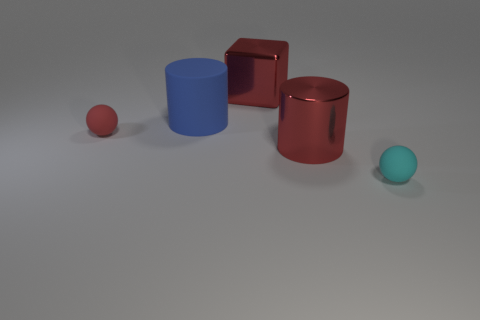Is the shape of the cyan matte thing the same as the red matte thing?
Offer a terse response. Yes. What is the material of the sphere that is the same color as the large cube?
Offer a terse response. Rubber. Is the color of the large shiny cylinder the same as the cylinder that is behind the small red object?
Offer a very short reply. No. The large shiny cylinder has what color?
Keep it short and to the point. Red. How many things are tiny green balls or blue things?
Your answer should be compact. 1. There is a red sphere that is the same size as the cyan sphere; what material is it?
Provide a short and direct response. Rubber. There is a cyan sphere in front of the rubber cylinder; what size is it?
Your response must be concise. Small. What is the material of the small red ball?
Provide a succinct answer. Rubber. How many objects are objects that are behind the large blue cylinder or matte objects to the left of the cyan sphere?
Keep it short and to the point. 3. What number of other objects are the same color as the matte cylinder?
Your response must be concise. 0. 